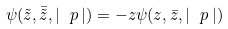<formula> <loc_0><loc_0><loc_500><loc_500>\psi ( \tilde { z } , \bar { \tilde { z } } , | \ p \, | ) = - z \psi ( z , \bar { z } , | \ p \, | )</formula> 